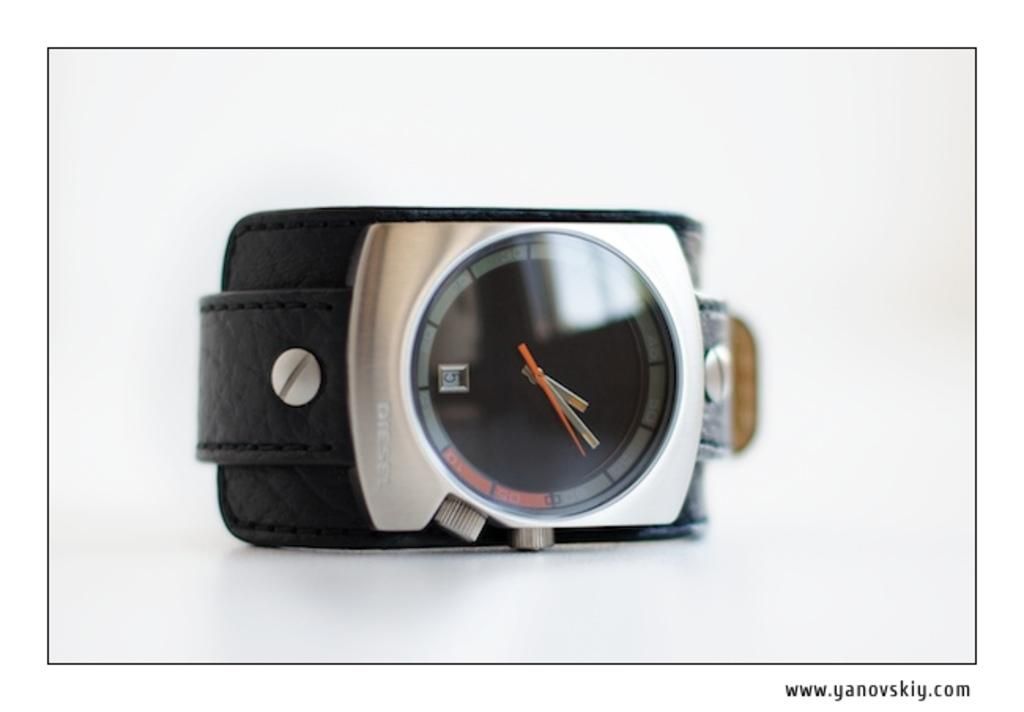<image>
Share a concise interpretation of the image provided. A Diesel wrist watch with a black band 